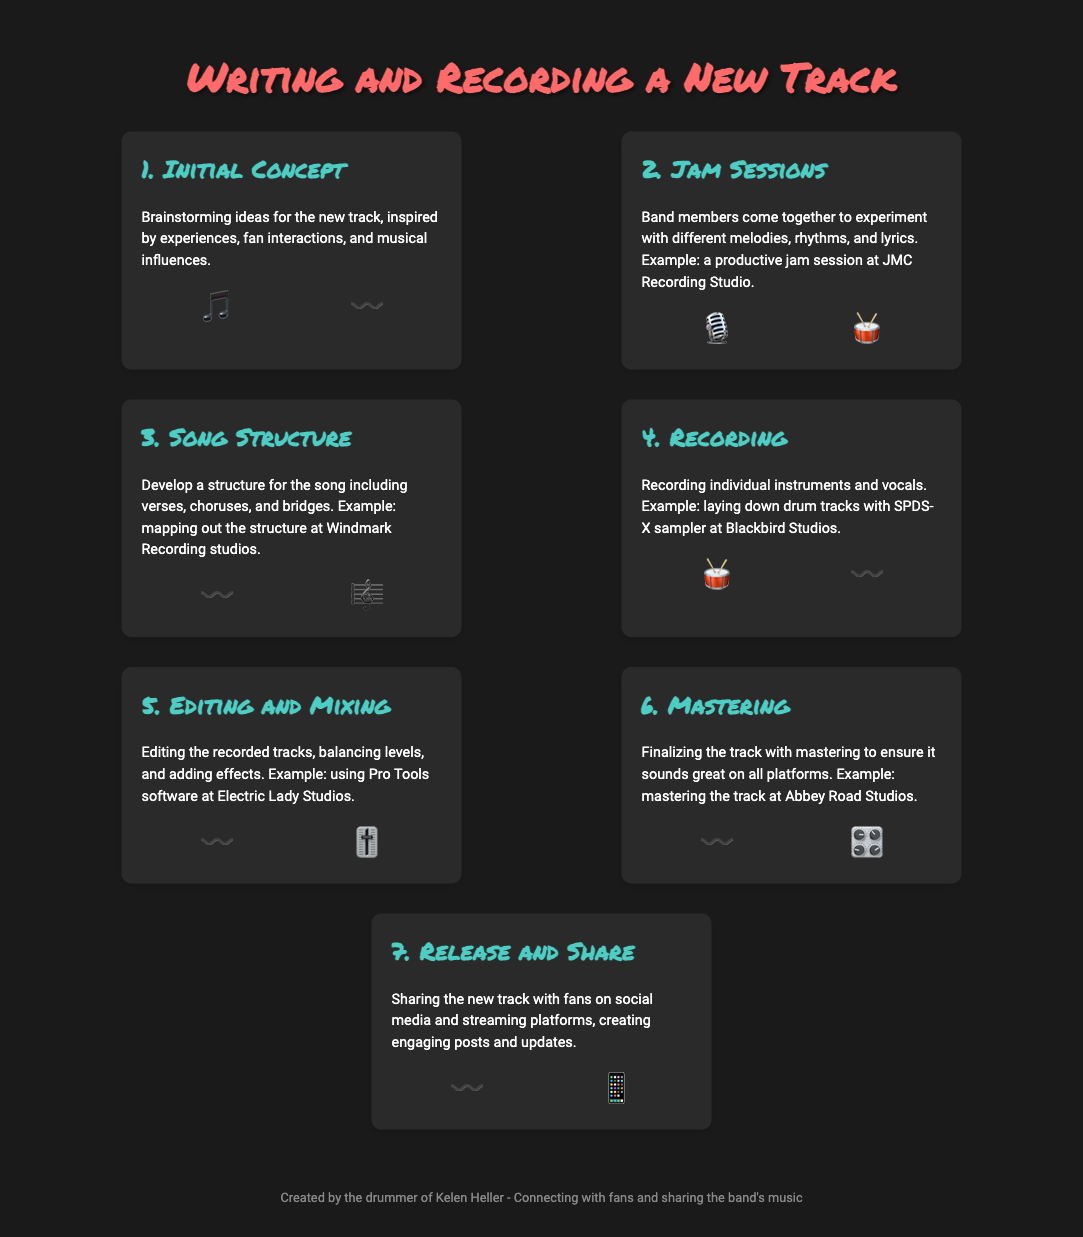What is the first step in the process? The first step in the process is outlined in the infographic as "Initial Concept".
Answer: Initial Concept What visual is used for the Recording step? The visual representing the Recording step consists of a drum emoji and a sound wave emoji.
Answer: 🥁 〰️ Which studio is mentioned for the Editing and Mixing step? The infographic specifies Electric Lady Studios for the Editing and Mixing step.
Answer: Electric Lady Studios How many steps are there in the writing and recording process? The document outlines a total of seven steps involved in writing and recording a new track.
Answer: 7 What is the final step in the process? The last step of the process shared in the infographic is to "Release and Share" the track.
Answer: Release and Share Which emoji symbolizes sharing on social media in the last step? The emoji used to represent sharing on social media in the final step is a mobile phone emoji.
Answer: 📱 What does the Editing and Mixing step involve? The Editing and Mixing step includes editing the recorded tracks, balancing levels, and adding effects.
Answer: Editing the recorded tracks What is emphasized in the Initial Concept step? The Initial Concept step emphasizes brainstorming ideas for the new track.
Answer: Brainstorming ideas 